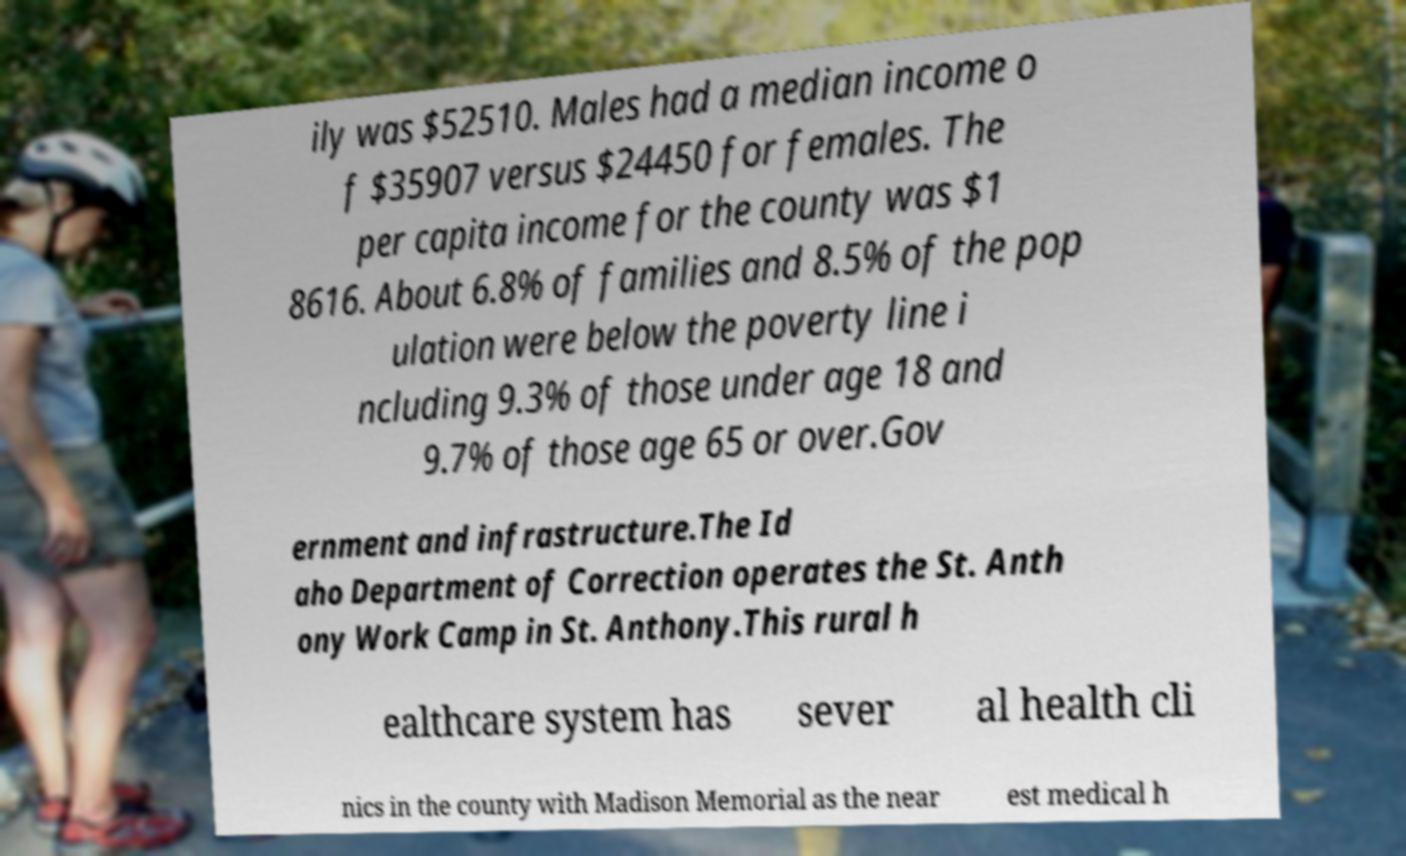Please read and relay the text visible in this image. What does it say? ily was $52510. Males had a median income o f $35907 versus $24450 for females. The per capita income for the county was $1 8616. About 6.8% of families and 8.5% of the pop ulation were below the poverty line i ncluding 9.3% of those under age 18 and 9.7% of those age 65 or over.Gov ernment and infrastructure.The Id aho Department of Correction operates the St. Anth ony Work Camp in St. Anthony.This rural h ealthcare system has sever al health cli nics in the county with Madison Memorial as the near est medical h 